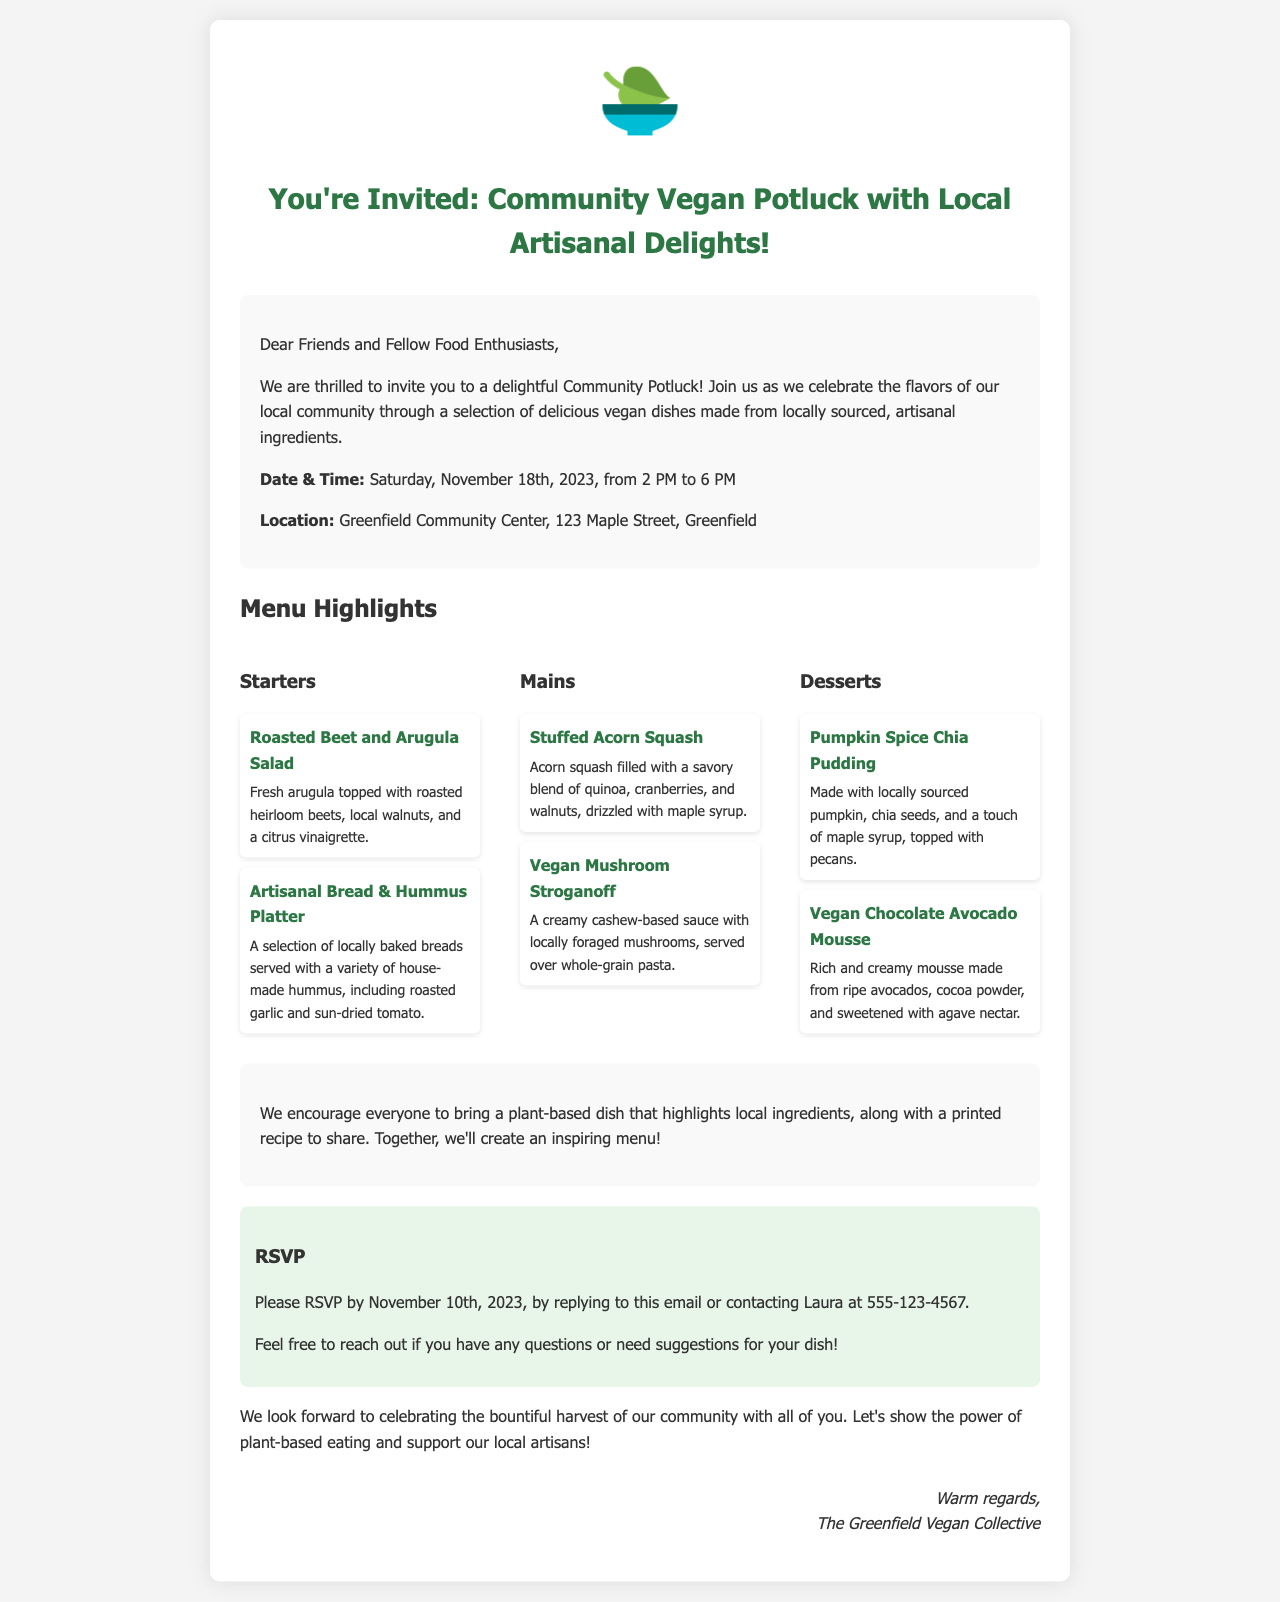What is the date of the potluck? The date of the potluck is specifically mentioned in the document.
Answer: Saturday, November 18th, 2023 What is the location of the event? The location provides the name and address where the event will take place.
Answer: Greenfield Community Center, 123 Maple Street, Greenfield What is one of the starters on the menu? The document lists specific menu items under different categories.
Answer: Roasted Beet and Arugula Salad What is the last date to RSVP? The RSVP deadline is clearly stated within the content.
Answer: November 10th, 2023 Who should be contacted for RSVP? The document specifies the name of the contact person for RSVPs.
Answer: Laura What type of dish should attendees bring? The invitation encourages a specific type of dish from the attendees.
Answer: Plant-based dish What time does the potluck start? The starting time of the event is explicitly outlined in the document.
Answer: 2 PM What is included in the Vegan Mushroom Stroganoff description? The description details the main components of the dish mentioned in the menu.
Answer: Creamy cashew-based sauce with locally foraged mushrooms What is the theme of this potluck? The overall theme of the event is highlighted in the introduction.
Answer: Vegan dishes made from locally sourced, artisanal ingredients 